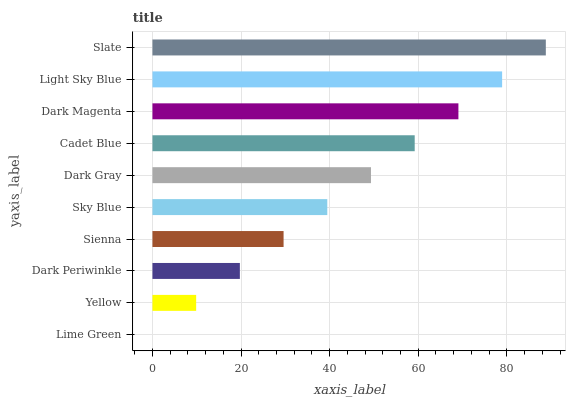Is Lime Green the minimum?
Answer yes or no. Yes. Is Slate the maximum?
Answer yes or no. Yes. Is Yellow the minimum?
Answer yes or no. No. Is Yellow the maximum?
Answer yes or no. No. Is Yellow greater than Lime Green?
Answer yes or no. Yes. Is Lime Green less than Yellow?
Answer yes or no. Yes. Is Lime Green greater than Yellow?
Answer yes or no. No. Is Yellow less than Lime Green?
Answer yes or no. No. Is Dark Gray the high median?
Answer yes or no. Yes. Is Sky Blue the low median?
Answer yes or no. Yes. Is Yellow the high median?
Answer yes or no. No. Is Dark Gray the low median?
Answer yes or no. No. 